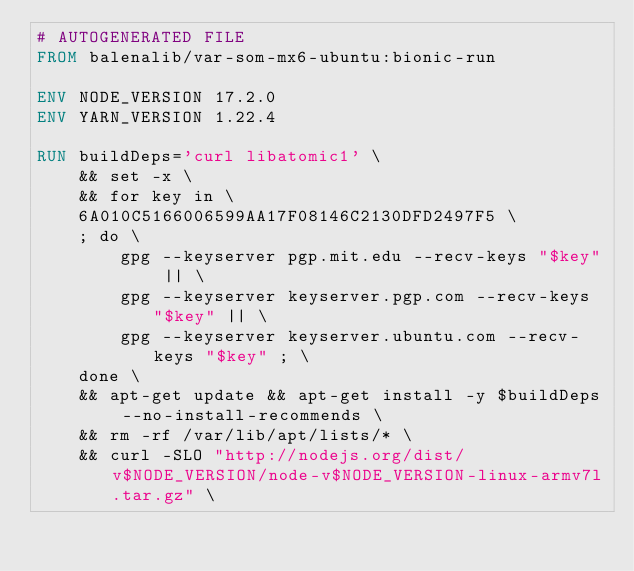<code> <loc_0><loc_0><loc_500><loc_500><_Dockerfile_># AUTOGENERATED FILE
FROM balenalib/var-som-mx6-ubuntu:bionic-run

ENV NODE_VERSION 17.2.0
ENV YARN_VERSION 1.22.4

RUN buildDeps='curl libatomic1' \
	&& set -x \
	&& for key in \
	6A010C5166006599AA17F08146C2130DFD2497F5 \
	; do \
		gpg --keyserver pgp.mit.edu --recv-keys "$key" || \
		gpg --keyserver keyserver.pgp.com --recv-keys "$key" || \
		gpg --keyserver keyserver.ubuntu.com --recv-keys "$key" ; \
	done \
	&& apt-get update && apt-get install -y $buildDeps --no-install-recommends \
	&& rm -rf /var/lib/apt/lists/* \
	&& curl -SLO "http://nodejs.org/dist/v$NODE_VERSION/node-v$NODE_VERSION-linux-armv7l.tar.gz" \</code> 